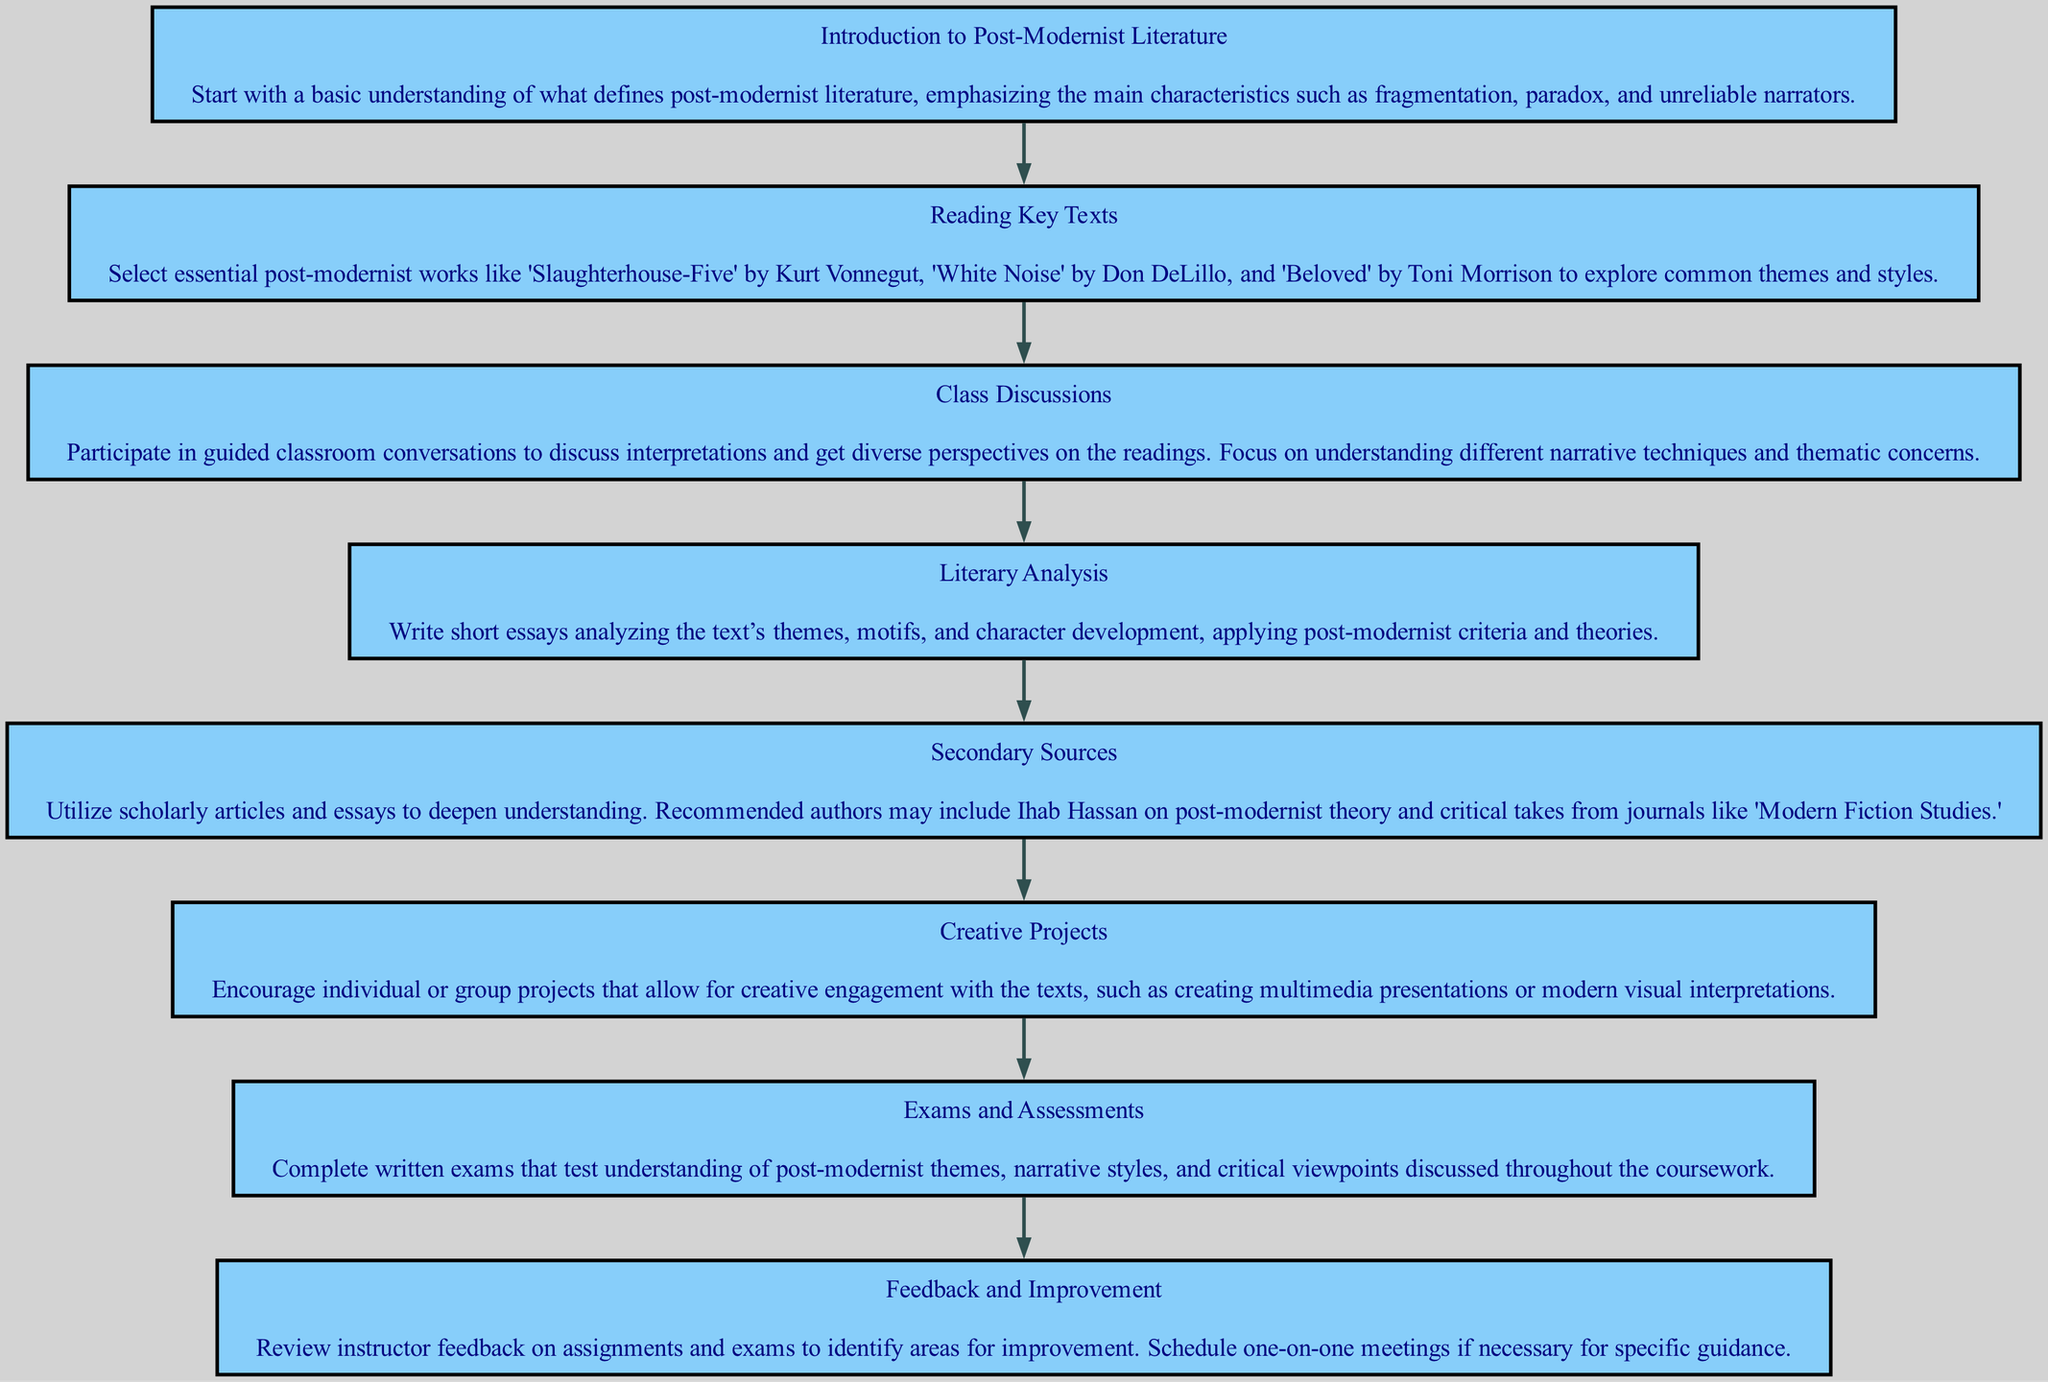What is the first step in the pathway? The first step in the pathway is labeled "Introduction to Post-Modernist Literature" located at the top of the diagram, which indicates the starting point of the clinical pathway.
Answer: Introduction to Post-Modernist Literature How many steps are included in the clinical pathway? Counting the steps visually in the diagram, there are a total of eight distinct steps listed, each representing a different stage in navigating high school literature courses focused on post-modernist works.
Answer: Eight What is the last step of the pathway? The last step listed in the pathway is "Feedback and Improvement," which appears at the bottom, indicating it concludes the flow of the clinical pathway.
Answer: Feedback and Improvement Which step involves writing essays? The step that involves writing essays is "Literary Analysis," as described in the diagram, which specifically mentions focusing on analyzing text themes and character development.
Answer: Literary Analysis What is the relationship between "Reading Key Texts" and "Class Discussions"? "Reading Key Texts" precedes "Class Discussions" in the flow of the diagram, indicating that understanding the readings leads to participation in discussions about those texts.
Answer: Sequential relationship In which step should scholarly articles be utilized? The step named "Secondary Sources" explicitly mentions the need to utilize scholarly articles and essays to deepen the understanding of post-modernist literature.
Answer: Secondary Sources How does "Creative Projects" relate to the overall learning process? "Creative Projects" follows reading and analyzing the texts, suggesting that it is a blend of understanding and creative engagement with the literature, which serves as a more hands-on application of the previous steps.
Answer: Hands-on application What type of assessments are included in the pathway? The pathway mentions "Exams and Assessments," which refer to the formal written evaluations intended to test understanding of post-modernist themes and styles discussed throughout the courses.
Answer: Written exams 